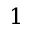Convert formula to latex. <formula><loc_0><loc_0><loc_500><loc_500>1</formula> 